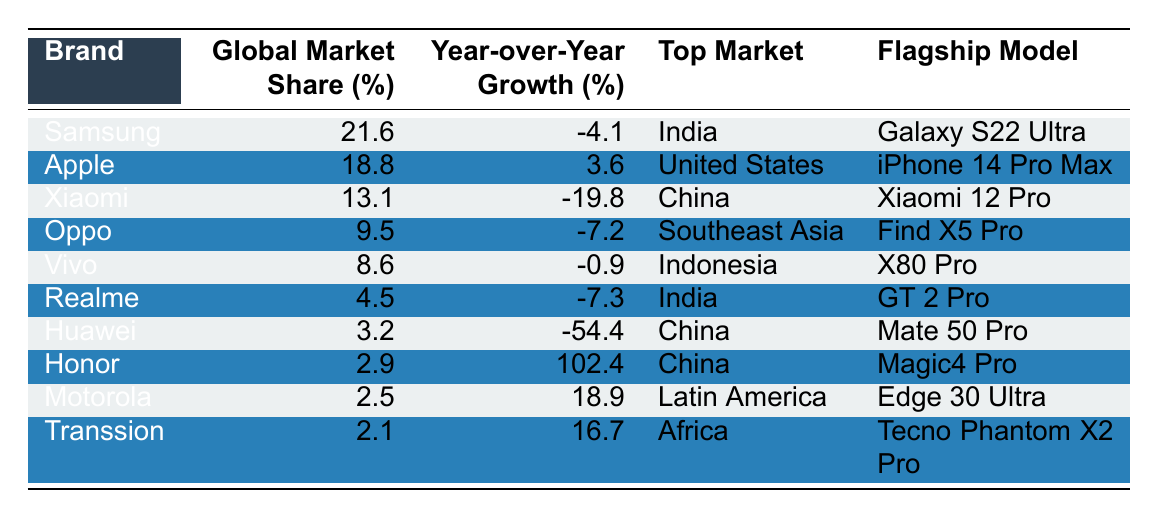What is the global market share of Samsung in 2022? Referring to the table, Samsung's global market share is specifically listed as 21.6%.
Answer: 21.6% Which brand experienced the highest year-over-year growth? Looking at the "Year-over-Year Growth" column, Honor has the highest growth percentage at 102.4%.
Answer: Honor What flagship model does Xiaomi offer? The table lists the flagship model for Xiaomi as the "Xiaomi 12 Pro".
Answer: Xiaomi 12 Pro How many brands have a global market share of less than 5%? By examining the "Global Market Share" column, Realme (4.5%), Huawei (3.2%), Honor (2.9%), Motorola (2.5%), and Transsion (2.1%) are below 5%. Thus, there are 5 brands.
Answer: 5 What is the average global market share among the listed brands? To find the average, we sum the market shares: (21.6 + 18.8 + 13.1 + 9.5 + 8.6 + 4.5 + 3.2 + 2.9 + 2.5 + 2.1) = 82.6. This total divided by 10 brand entries gives an average of 82.6 / 10 = 8.26%.
Answer: 8.26% Is it true that both Oppo and Vivo have a negative year-over-year growth? Checking the "Year-over-Year Growth" column, Oppo's growth is -7.2% and Vivo’s is -0.9%, confirming that both have negative growth.
Answer: Yes Which brand has the largest market share in its top market? Samsung has the largest market share (21.6%) and operates primarily in India, which is its top market.
Answer: Samsung Calculate the difference in market share between Apple and Huawei. Apple has a market share of 18.8% while Huawei has 3.2%. The difference is 18.8 - 3.2 = 15.6%.
Answer: 15.6% Which brands are primarily focused on the Chinese market? From the table, Xiaomi, Huawei, and Honor have their top market listed as China.
Answer: Xiaomi, Huawei, Honor What percentage of the brands listed are not experiencing growth? The brands with negative year-over-year growth are Samsung (-4.1%), Xiaomi (-19.8%), Oppo (-7.2%), Realme (-7.3%), Huawei (-54.4%). Out of 10 brands, 5 have negative growth, so 5/10 = 50%.
Answer: 50% 